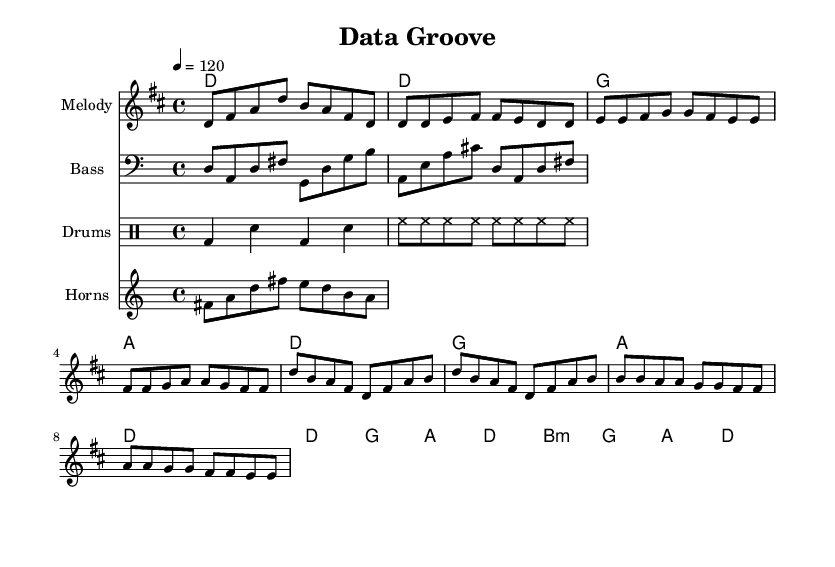What is the key signature of this music? The key signature is D major, which contains two sharps (F# and C#). This is determined by checking the key signature indicator at the beginning of the score.
Answer: D major What is the time signature of this piece? The time signature is 4/4, indicated at the beginning of the score. This means there are four beats per measure, and the quarter note receives one beat.
Answer: 4/4 What is the tempo marking for this music? The tempo is marked as 120 beats per minute, indicated by the tempo directive at the beginning of the score. This sets the speed at which the piece should be played.
Answer: 120 How many measures are in the verse section? The verse section consists of 8 measures, counting each measure in the melody part that corresponds to the verse segment.
Answer: 8 What chord follows the G chord in the chorus? The chord following the G chord in the chorus is A. This can be found by looking at the harmony part during the chorus section where the chords are listed.
Answer: A What is the instrumentation used in this piece? The instrumentation includes melody, bass, drums, and horns. Each part is indicated by a separate staff in the score.
Answer: Melody, Bass, Drums, Horns How does the horn riff relate to the melody? The horn riff complements the melody as it provides a harmonic and rhythmic layer. It is played in a similar rhythmic pattern and incorporates notes from the melody, enriching the overall sound.
Answer: Complementary 